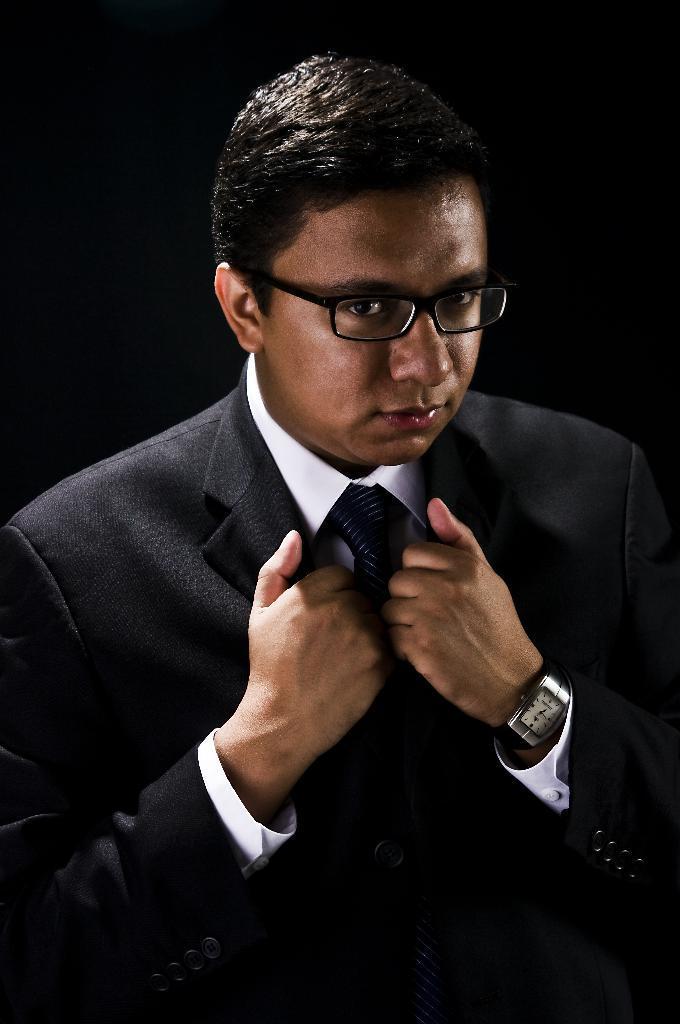Describe this image in one or two sentences. In this picture there is a man wore spectacle. In the background of the image it is dark. 